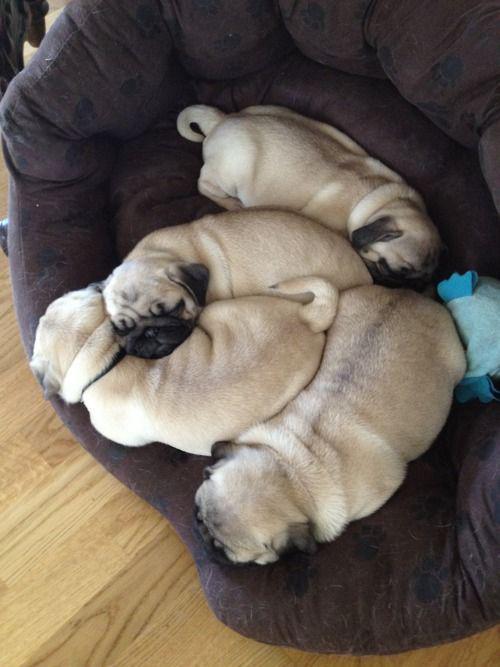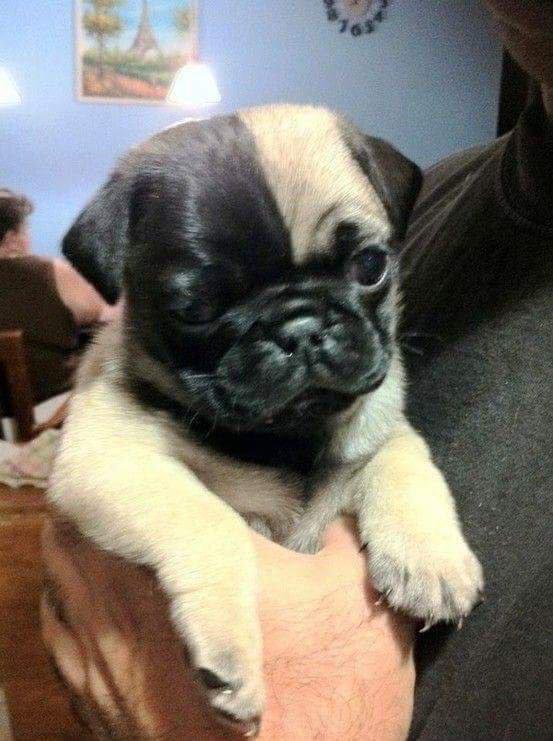The first image is the image on the left, the second image is the image on the right. For the images shown, is this caption "Each image includes buff-beige pugs with dark muzzles, and no image contains fewer than three pugs." true? Answer yes or no. No. The first image is the image on the left, the second image is the image on the right. For the images displayed, is the sentence "There are more dogs in the image on the right." factually correct? Answer yes or no. No. 